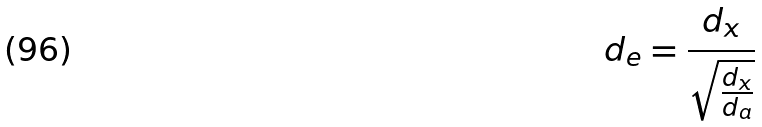<formula> <loc_0><loc_0><loc_500><loc_500>d _ { e } = \frac { d _ { x } } { \sqrt { \frac { d _ { x } } { d _ { a } } } }</formula> 